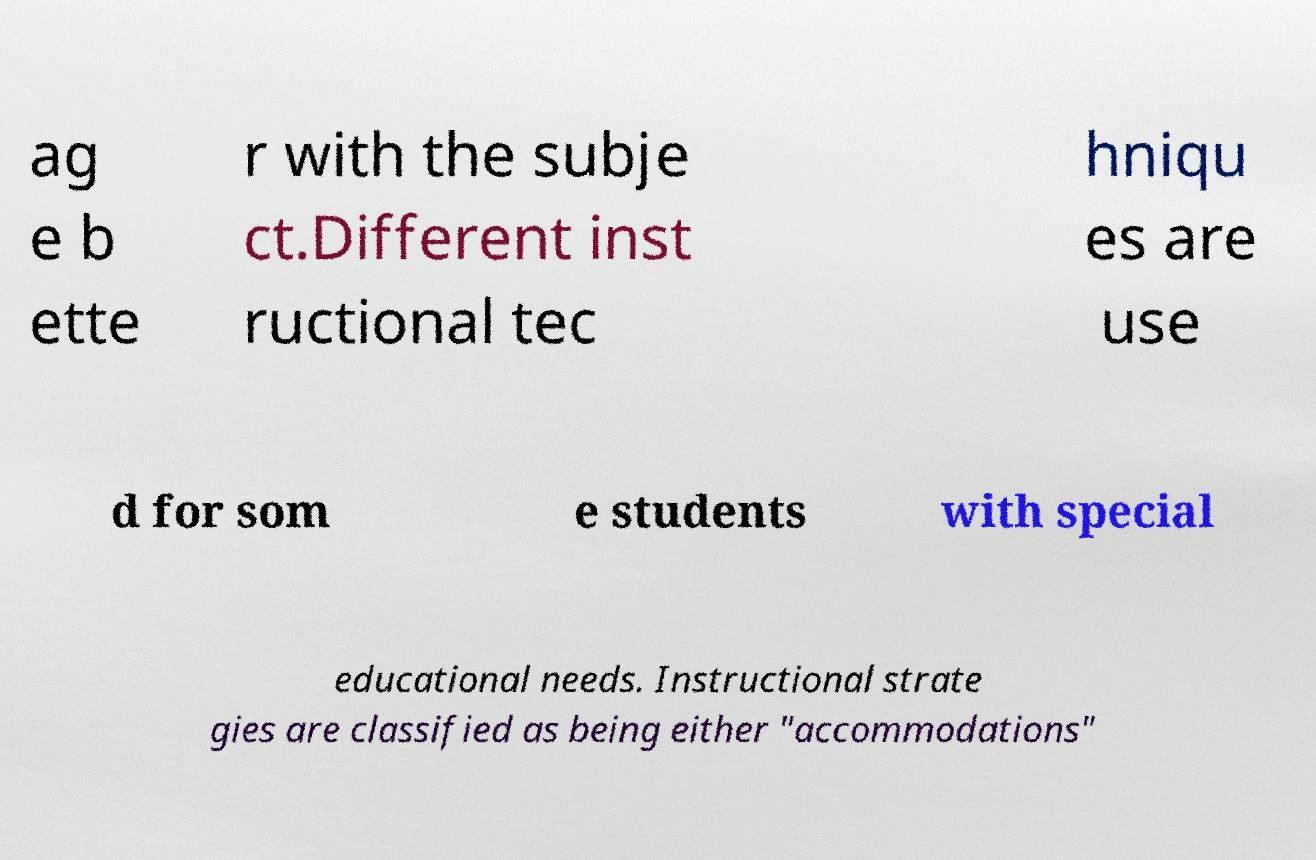What messages or text are displayed in this image? I need them in a readable, typed format. ag e b ette r with the subje ct.Different inst ructional tec hniqu es are use d for som e students with special educational needs. Instructional strate gies are classified as being either "accommodations" 